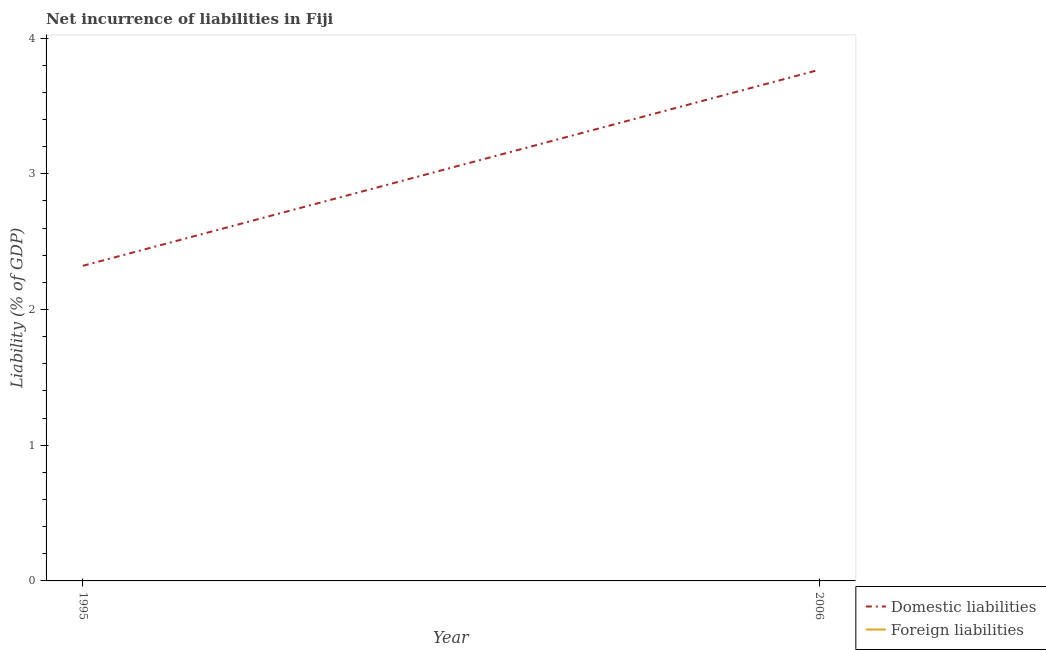How many different coloured lines are there?
Make the answer very short. 1. What is the incurrence of domestic liabilities in 2006?
Ensure brevity in your answer.  3.77. Across all years, what is the maximum incurrence of domestic liabilities?
Make the answer very short. 3.77. Across all years, what is the minimum incurrence of domestic liabilities?
Ensure brevity in your answer.  2.32. What is the total incurrence of domestic liabilities in the graph?
Make the answer very short. 6.09. What is the difference between the incurrence of domestic liabilities in 1995 and that in 2006?
Your response must be concise. -1.44. What is the difference between the incurrence of domestic liabilities in 2006 and the incurrence of foreign liabilities in 1995?
Give a very brief answer. 3.77. What is the average incurrence of domestic liabilities per year?
Make the answer very short. 3.04. What is the ratio of the incurrence of domestic liabilities in 1995 to that in 2006?
Make the answer very short. 0.62. Is the incurrence of domestic liabilities in 1995 less than that in 2006?
Offer a very short reply. Yes. In how many years, is the incurrence of domestic liabilities greater than the average incurrence of domestic liabilities taken over all years?
Provide a short and direct response. 1. Is the incurrence of domestic liabilities strictly greater than the incurrence of foreign liabilities over the years?
Ensure brevity in your answer.  Yes. How many years are there in the graph?
Give a very brief answer. 2. What is the difference between two consecutive major ticks on the Y-axis?
Keep it short and to the point. 1. Does the graph contain grids?
Give a very brief answer. No. Where does the legend appear in the graph?
Your answer should be very brief. Bottom right. What is the title of the graph?
Ensure brevity in your answer.  Net incurrence of liabilities in Fiji. Does "Registered firms" appear as one of the legend labels in the graph?
Your response must be concise. No. What is the label or title of the Y-axis?
Keep it short and to the point. Liability (% of GDP). What is the Liability (% of GDP) in Domestic liabilities in 1995?
Make the answer very short. 2.32. What is the Liability (% of GDP) in Foreign liabilities in 1995?
Provide a succinct answer. 0. What is the Liability (% of GDP) of Domestic liabilities in 2006?
Provide a short and direct response. 3.77. Across all years, what is the maximum Liability (% of GDP) in Domestic liabilities?
Keep it short and to the point. 3.77. Across all years, what is the minimum Liability (% of GDP) in Domestic liabilities?
Your answer should be compact. 2.32. What is the total Liability (% of GDP) in Domestic liabilities in the graph?
Your answer should be compact. 6.09. What is the difference between the Liability (% of GDP) in Domestic liabilities in 1995 and that in 2006?
Your answer should be compact. -1.44. What is the average Liability (% of GDP) in Domestic liabilities per year?
Offer a terse response. 3.04. What is the ratio of the Liability (% of GDP) in Domestic liabilities in 1995 to that in 2006?
Keep it short and to the point. 0.62. What is the difference between the highest and the second highest Liability (% of GDP) in Domestic liabilities?
Provide a short and direct response. 1.44. What is the difference between the highest and the lowest Liability (% of GDP) of Domestic liabilities?
Give a very brief answer. 1.44. 